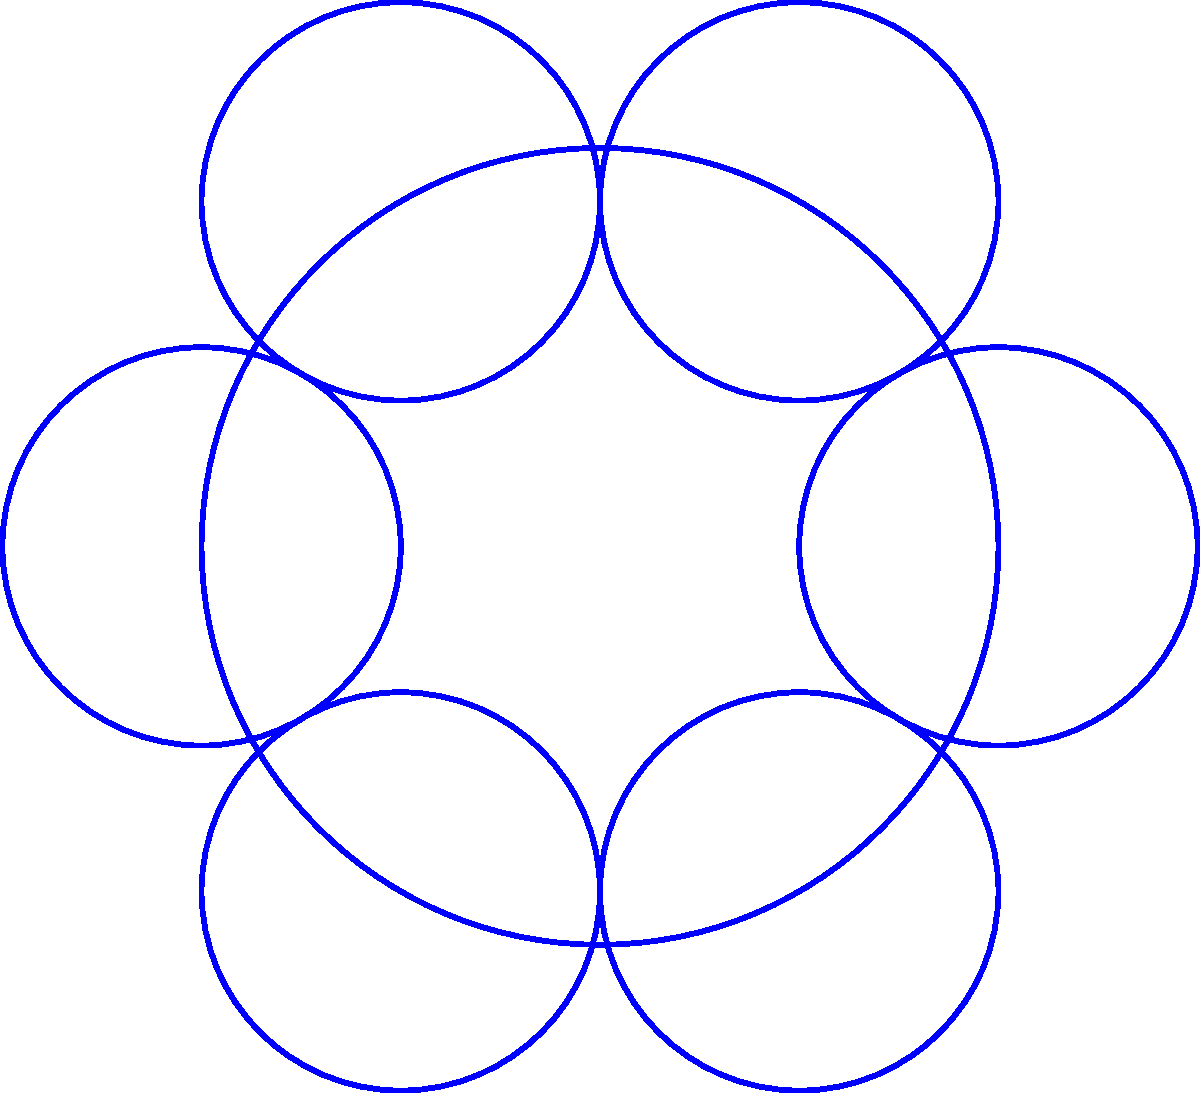In the mandala pattern shown, a regular hexagon is inscribed within the central circle. If the radius of the outer circle is $R$, what is the side length of the hexagon in terms of $R$? Let's approach this step-by-step:

1) In a regular hexagon, the radius of the circumscribed circle is equal to the side length. Let's call the side length of the hexagon $s$.

2) From the diagram, we can see that the radius of the circle containing the hexagon is half the radius of the outer circle. So, the radius of the circle containing the hexagon is $\frac{R}{2}$.

3) Since the radius of the circle containing the hexagon is equal to the side length of the hexagon, we can conclude:

   $s = \frac{R}{2}$

4) Therefore, the side length of the hexagon is half the radius of the outer circle.

This relationship between the radius of a circle and the side length of an inscribed regular hexagon is a fundamental property in geometry, often used in creating symmetrical patterns like mandalas.
Answer: $\frac{R}{2}$ 